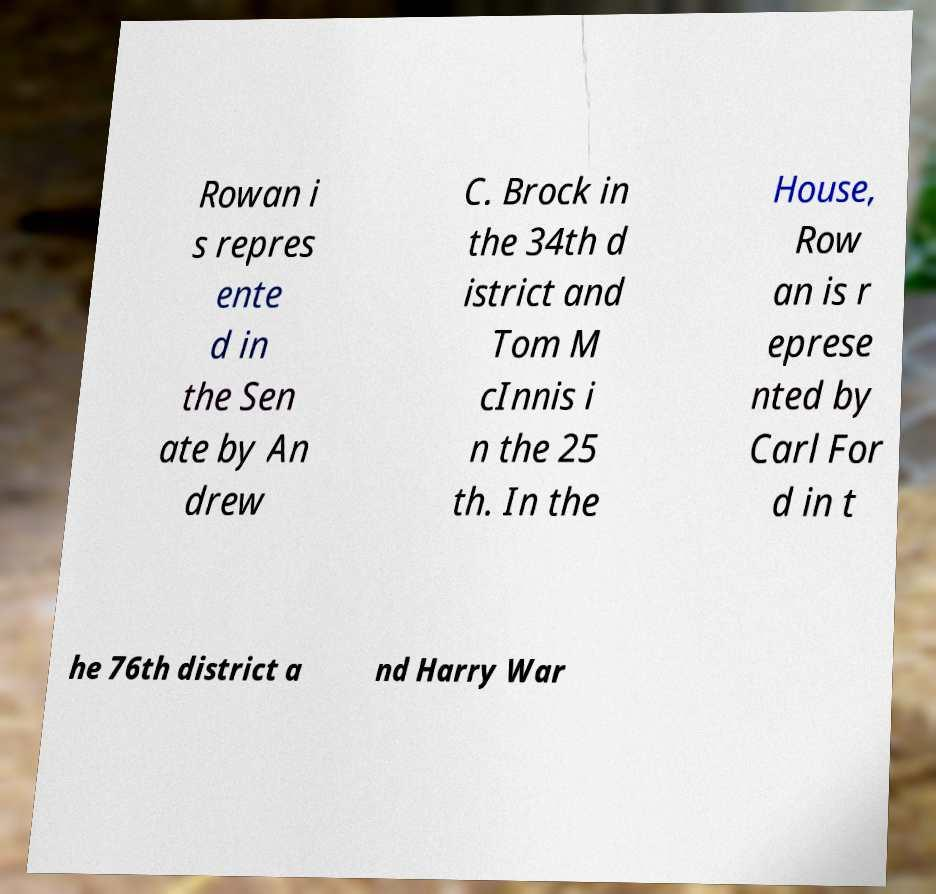For documentation purposes, I need the text within this image transcribed. Could you provide that? Rowan i s repres ente d in the Sen ate by An drew C. Brock in the 34th d istrict and Tom M cInnis i n the 25 th. In the House, Row an is r eprese nted by Carl For d in t he 76th district a nd Harry War 